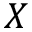Convert formula to latex. <formula><loc_0><loc_0><loc_500><loc_500>X</formula> 